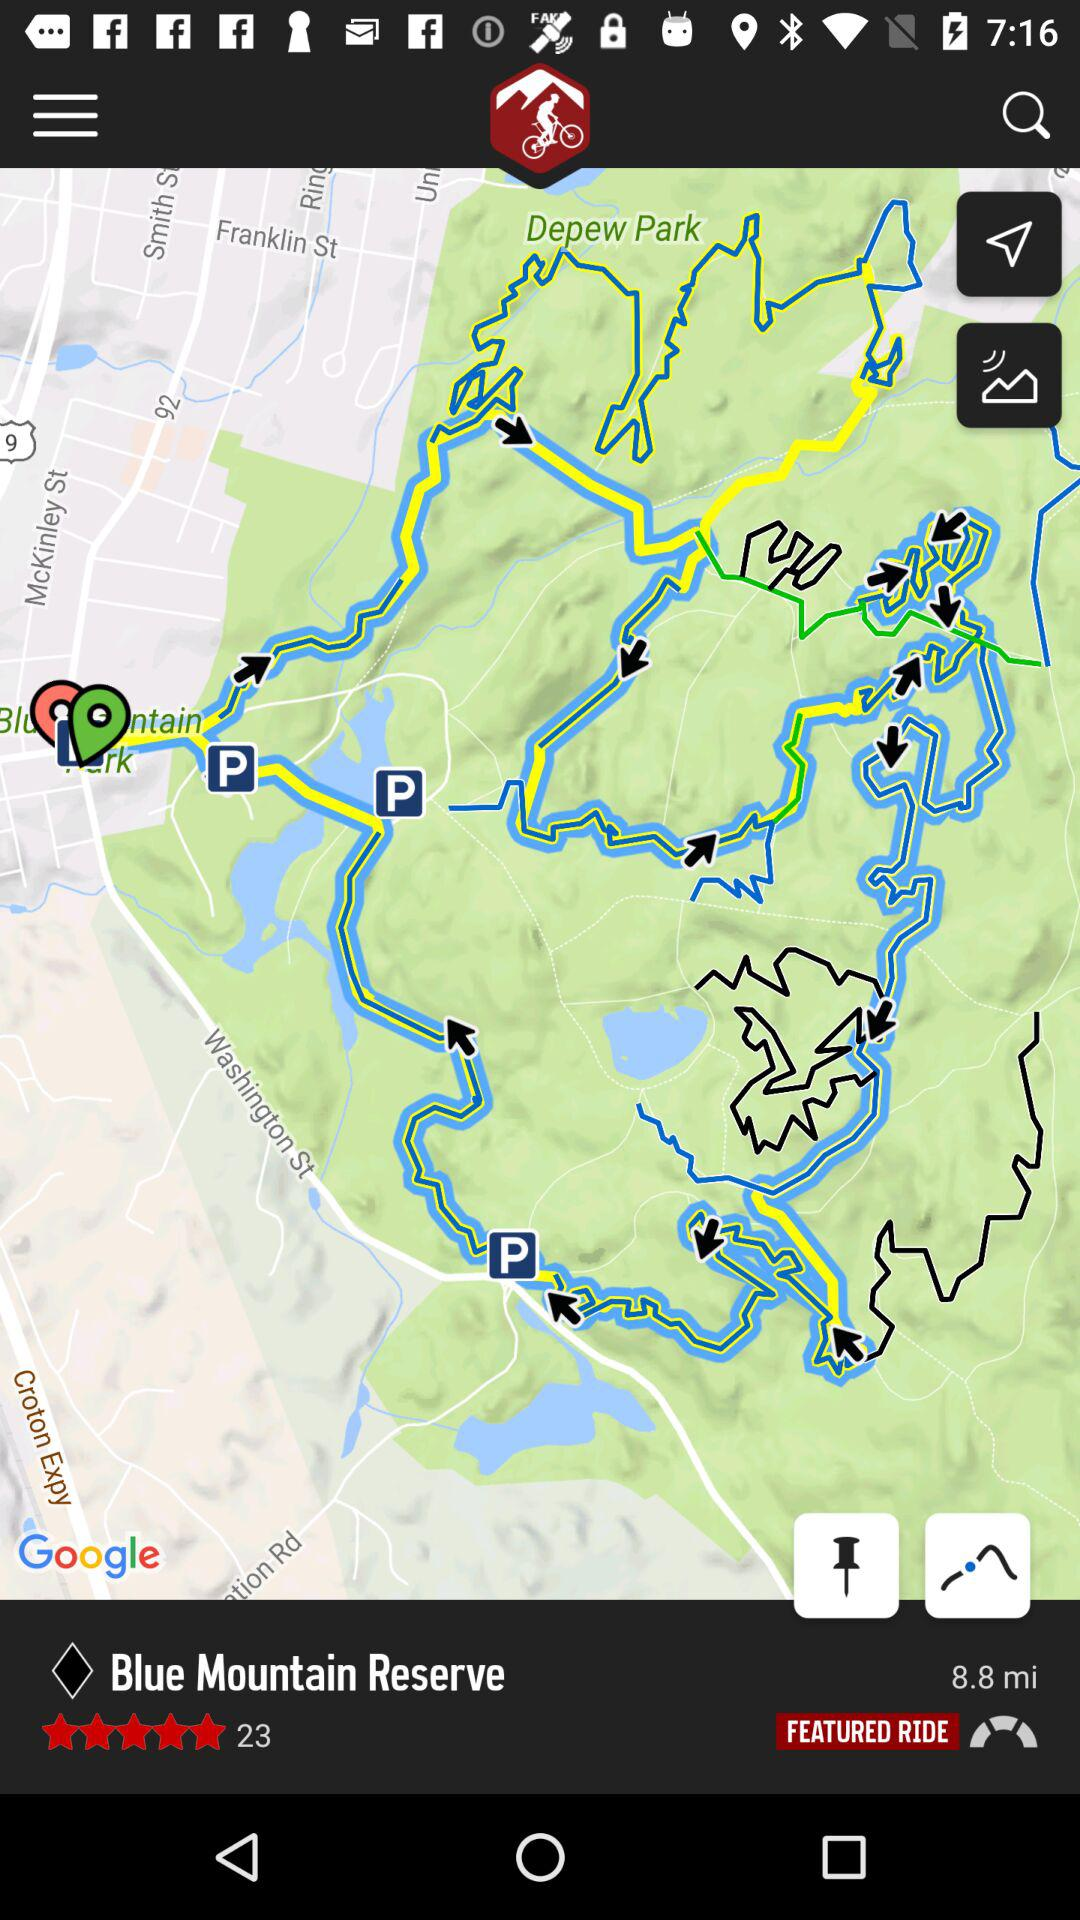Which place has been seen on the map? The place is Blue Mountain Reserve. 